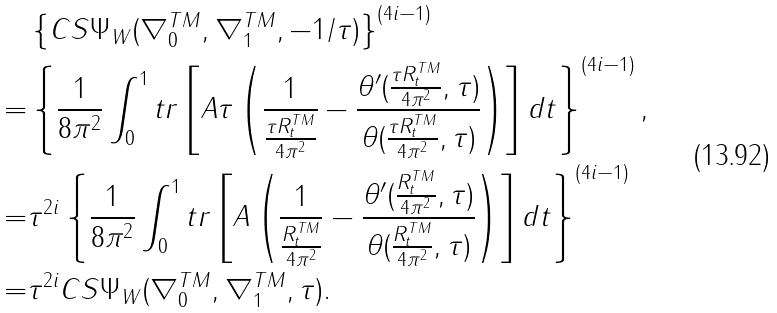<formula> <loc_0><loc_0><loc_500><loc_500>& \left \{ C S \Psi _ { W } ( \nabla _ { 0 } ^ { T M } , \nabla _ { 1 } ^ { T M } , - { 1 } / { \tau } ) \right \} ^ { ( 4 i - 1 ) } \\ = & \left \{ { \frac { 1 } { 8 \pi ^ { 2 } } } \int _ { 0 } ^ { 1 } t r \left [ A \tau \left ( \frac { 1 } { \frac { \tau R _ { t } ^ { T M } } { 4 \pi ^ { 2 } } } - \frac { \theta ^ { \prime } ( \frac { \tau R _ { t } ^ { T M } } { 4 \pi ^ { 2 } } , \tau ) } { \theta ( \frac { \tau R _ { t } ^ { T M } } { 4 \pi ^ { 2 } } , \tau ) } \right ) \right ] d t \right \} ^ { ( 4 i - 1 ) } , \\ = & \tau ^ { 2 i } \left \{ { \frac { 1 } { 8 \pi ^ { 2 } } } \int _ { 0 } ^ { 1 } t r \left [ A \left ( \frac { 1 } { \frac { R _ { t } ^ { T M } } { 4 \pi ^ { 2 } } } - \frac { \theta ^ { \prime } ( \frac { R _ { t } ^ { T M } } { 4 \pi ^ { 2 } } , \tau ) } { \theta ( \frac { R _ { t } ^ { T M } } { 4 \pi ^ { 2 } } , \tau ) } \right ) \right ] d t \right \} ^ { ( 4 i - 1 ) } \\ = & \tau ^ { 2 i } C S \Psi _ { W } ( \nabla _ { 0 } ^ { T M } , \nabla _ { 1 } ^ { T M } , \tau ) .</formula> 